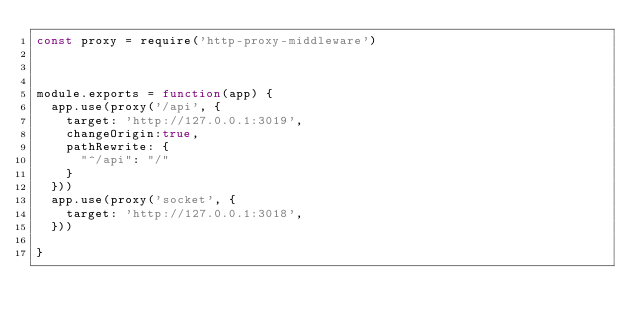Convert code to text. <code><loc_0><loc_0><loc_500><loc_500><_JavaScript_>const proxy = require('http-proxy-middleware')



module.exports = function(app) {
  app.use(proxy('/api', {   
    target: 'http://127.0.0.1:3019',
    changeOrigin:true,
    pathRewrite: {
      "^/api": "/"
    }
  }))
  app.use(proxy('socket', {   
    target: 'http://127.0.0.1:3018',
  }))
  
}
</code> 